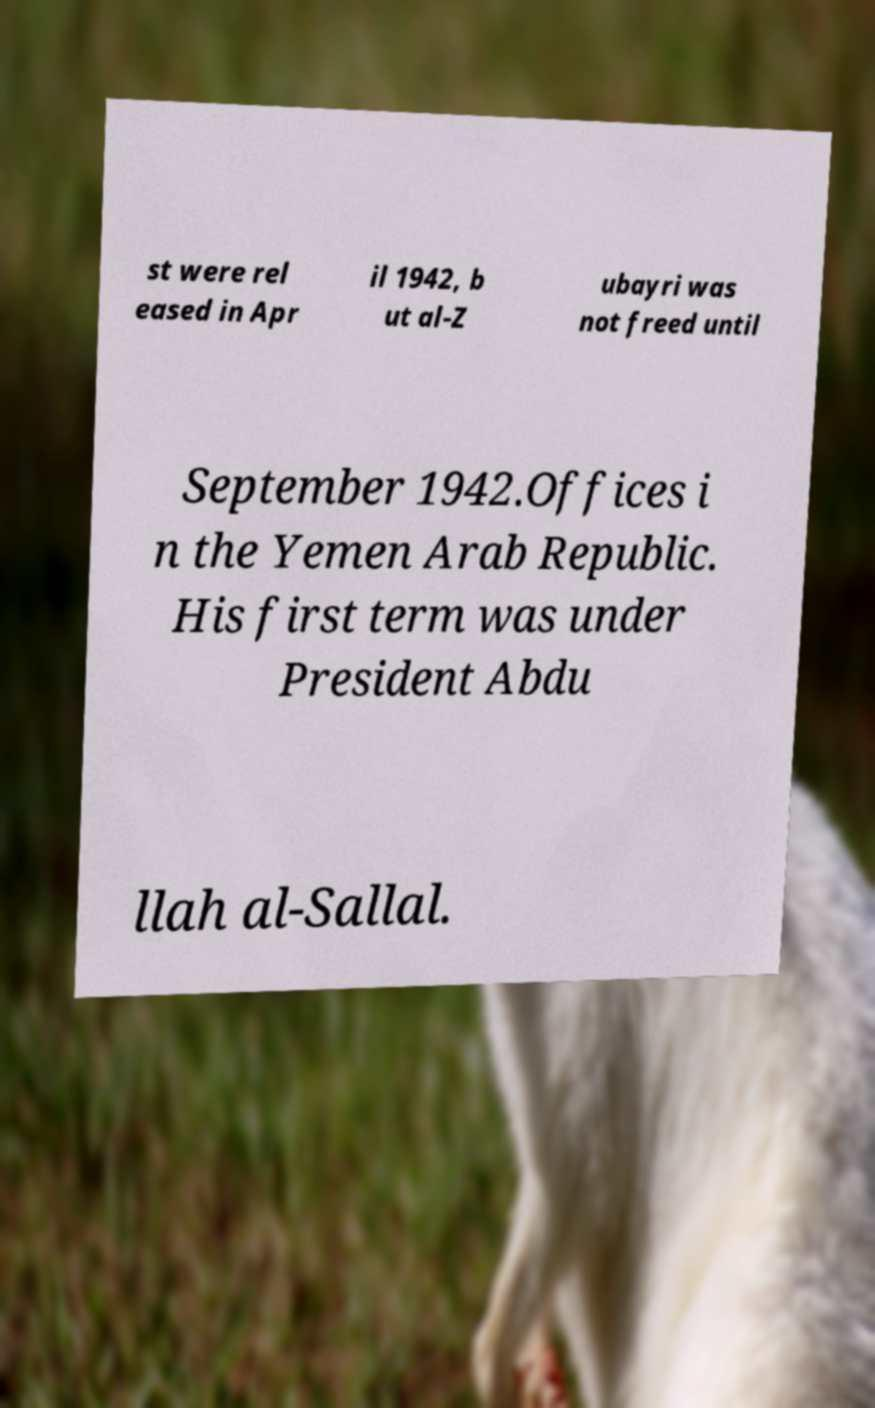For documentation purposes, I need the text within this image transcribed. Could you provide that? st were rel eased in Apr il 1942, b ut al-Z ubayri was not freed until September 1942.Offices i n the Yemen Arab Republic. His first term was under President Abdu llah al-Sallal. 